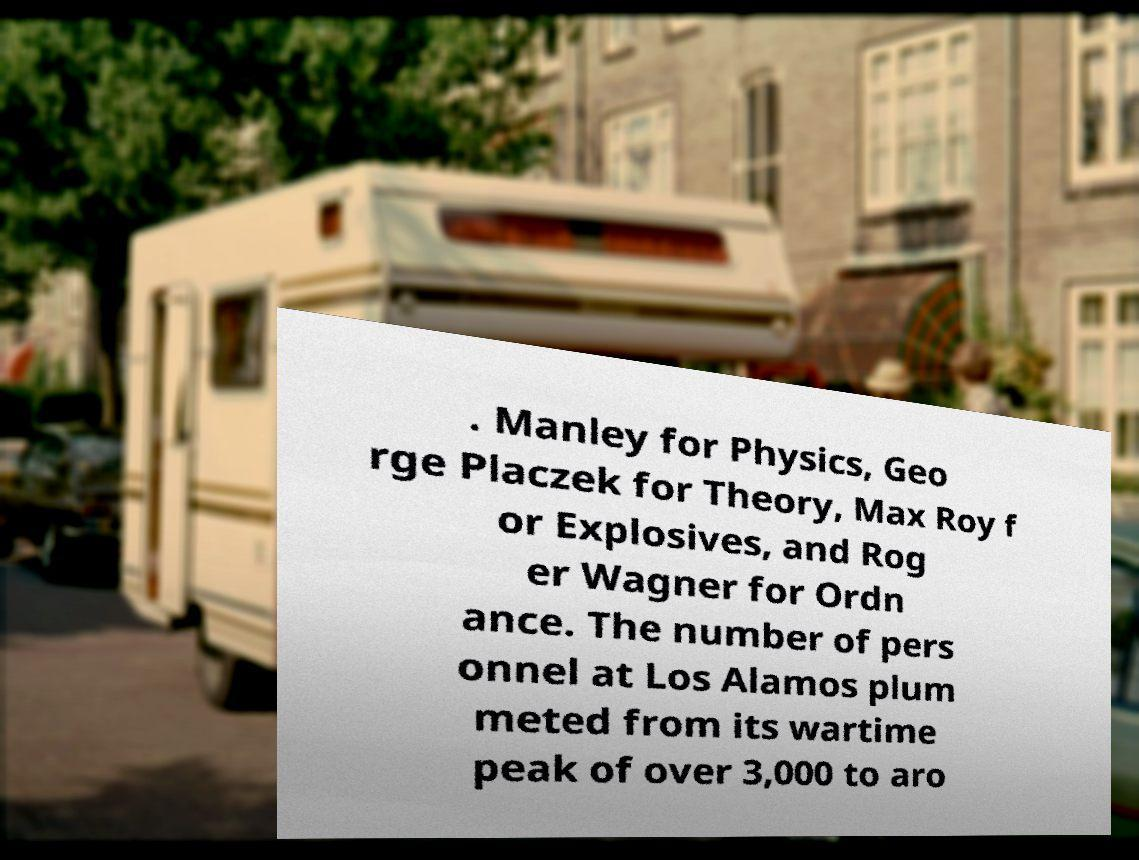There's text embedded in this image that I need extracted. Can you transcribe it verbatim? . Manley for Physics, Geo rge Placzek for Theory, Max Roy f or Explosives, and Rog er Wagner for Ordn ance. The number of pers onnel at Los Alamos plum meted from its wartime peak of over 3,000 to aro 